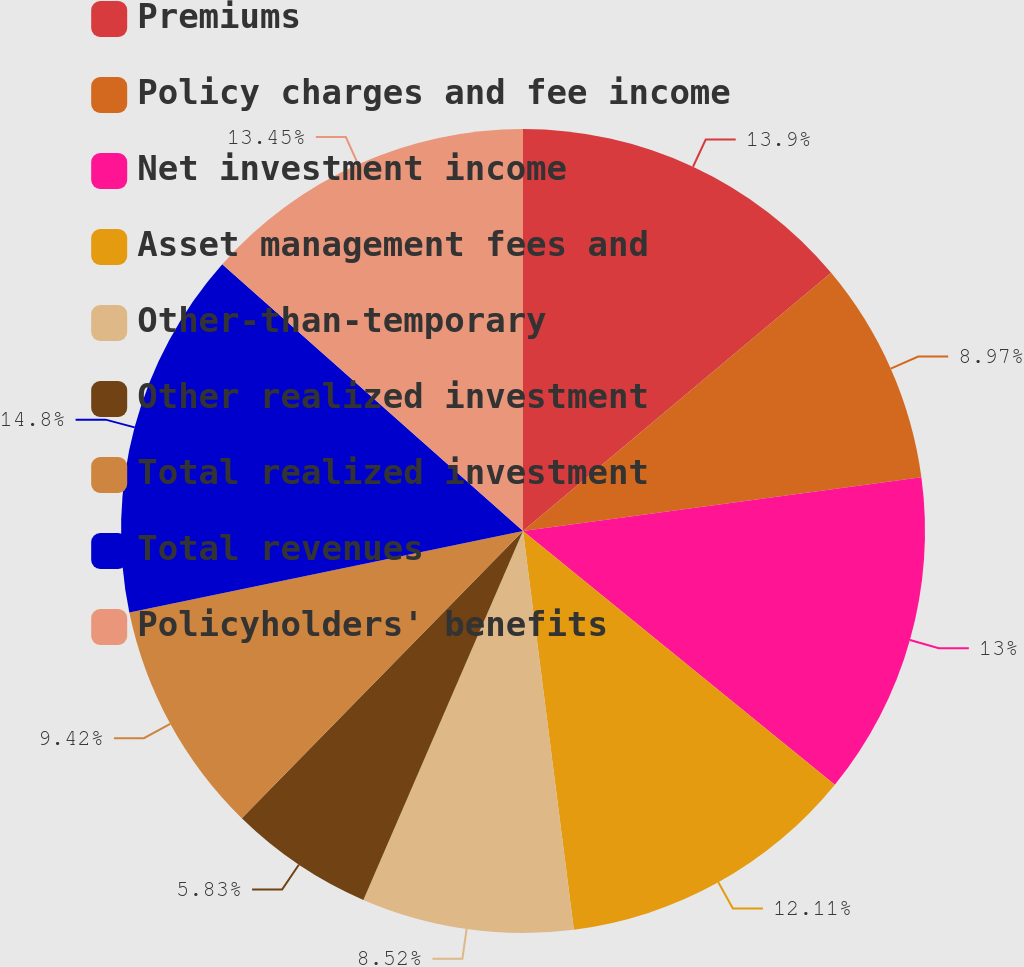Convert chart. <chart><loc_0><loc_0><loc_500><loc_500><pie_chart><fcel>Premiums<fcel>Policy charges and fee income<fcel>Net investment income<fcel>Asset management fees and<fcel>Other-than-temporary<fcel>Other realized investment<fcel>Total realized investment<fcel>Total revenues<fcel>Policyholders' benefits<nl><fcel>13.9%<fcel>8.97%<fcel>13.0%<fcel>12.11%<fcel>8.52%<fcel>5.83%<fcel>9.42%<fcel>14.8%<fcel>13.45%<nl></chart> 